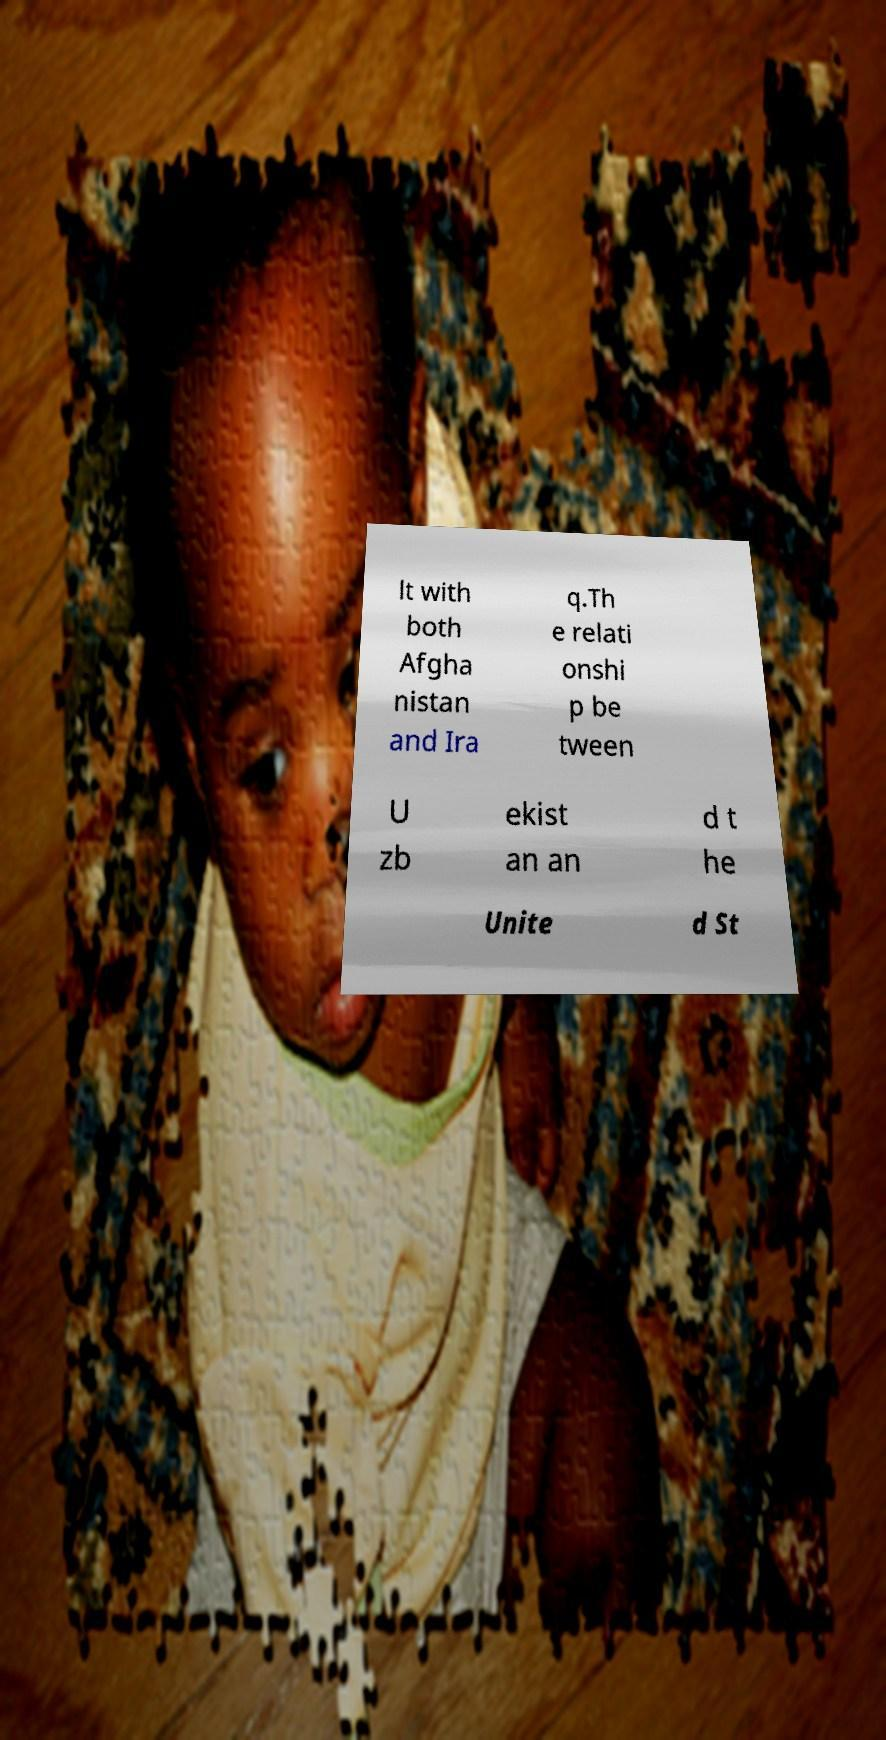I need the written content from this picture converted into text. Can you do that? lt with both Afgha nistan and Ira q.Th e relati onshi p be tween U zb ekist an an d t he Unite d St 